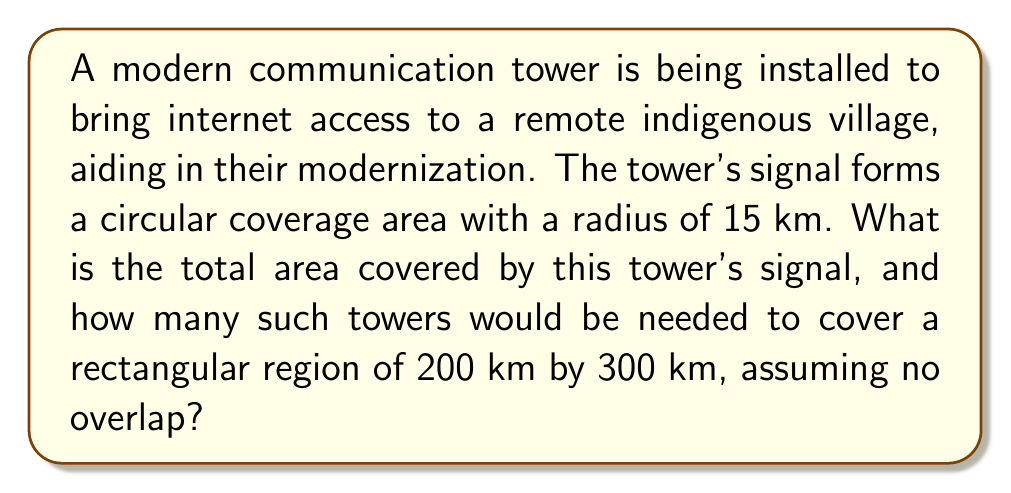Give your solution to this math problem. 1. Calculate the area covered by one tower:
   The coverage area is circular, so we use the formula for the area of a circle:
   $$A = \pi r^2$$
   where $r$ is the radius.
   $$A = \pi (15\text{ km})^2 = 225\pi \text{ km}^2 \approx 706.86 \text{ km}^2$$

2. Calculate the total area to be covered:
   The region is rectangular, so we use the formula for the area of a rectangle:
   $$A_{total} = length \times width = 200 \text{ km} \times 300 \text{ km} = 60,000 \text{ km}^2$$

3. Calculate the number of towers needed:
   Divide the total area by the area covered by one tower:
   $$\text{Number of towers} = \frac{A_{total}}{A_{one tower}} = \frac{60,000 \text{ km}^2}{225\pi \text{ km}^2} \approx 84.82$$

4. Round up to the nearest whole number, as we need full towers:
   85 towers would be needed.

[asy]
unitsize(1cm);
draw((0,0)--(10,0)--(10,15)--(0,15)--cycle);
fill(circle((2,2),1), rgb(0.8,0.8,1));
fill(circle((5,4),1), rgb(0.8,0.8,1));
fill(circle((8,2),1), rgb(0.8,0.8,1));
fill(circle((2,7),1), rgb(0.8,0.8,1));
fill(circle((5,9),1), rgb(0.8,0.8,1));
fill(circle((8,7),1), rgb(0.8,0.8,1));
fill(circle((2,12),1), rgb(0.8,0.8,1));
fill(circle((5,14),1), rgb(0.8,0.8,1));
fill(circle((8,12),1), rgb(0.8,0.8,1));
label("200 km", (5,0), S);
label("300 km", (10,7.5), E);
[/asy]
Answer: 706.86 km² per tower; 85 towers needed 